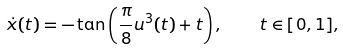Convert formula to latex. <formula><loc_0><loc_0><loc_500><loc_500>\dot { x } ( t ) = - \tan \left ( { \frac { \pi } { 8 } { u ^ { 3 } } ( t ) + t } \right ) , \quad t \in [ 0 , 1 ] ,</formula> 